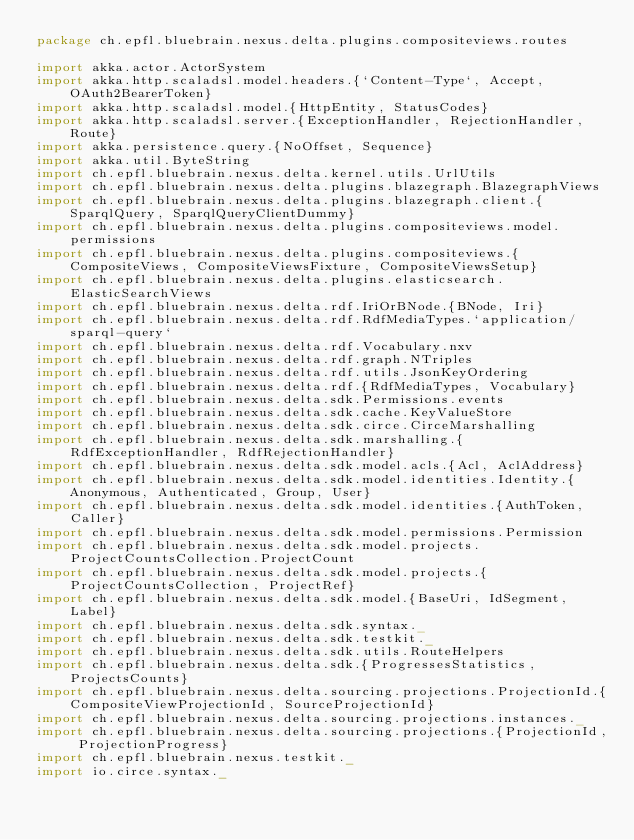<code> <loc_0><loc_0><loc_500><loc_500><_Scala_>package ch.epfl.bluebrain.nexus.delta.plugins.compositeviews.routes

import akka.actor.ActorSystem
import akka.http.scaladsl.model.headers.{`Content-Type`, Accept, OAuth2BearerToken}
import akka.http.scaladsl.model.{HttpEntity, StatusCodes}
import akka.http.scaladsl.server.{ExceptionHandler, RejectionHandler, Route}
import akka.persistence.query.{NoOffset, Sequence}
import akka.util.ByteString
import ch.epfl.bluebrain.nexus.delta.kernel.utils.UrlUtils
import ch.epfl.bluebrain.nexus.delta.plugins.blazegraph.BlazegraphViews
import ch.epfl.bluebrain.nexus.delta.plugins.blazegraph.client.{SparqlQuery, SparqlQueryClientDummy}
import ch.epfl.bluebrain.nexus.delta.plugins.compositeviews.model.permissions
import ch.epfl.bluebrain.nexus.delta.plugins.compositeviews.{CompositeViews, CompositeViewsFixture, CompositeViewsSetup}
import ch.epfl.bluebrain.nexus.delta.plugins.elasticsearch.ElasticSearchViews
import ch.epfl.bluebrain.nexus.delta.rdf.IriOrBNode.{BNode, Iri}
import ch.epfl.bluebrain.nexus.delta.rdf.RdfMediaTypes.`application/sparql-query`
import ch.epfl.bluebrain.nexus.delta.rdf.Vocabulary.nxv
import ch.epfl.bluebrain.nexus.delta.rdf.graph.NTriples
import ch.epfl.bluebrain.nexus.delta.rdf.utils.JsonKeyOrdering
import ch.epfl.bluebrain.nexus.delta.rdf.{RdfMediaTypes, Vocabulary}
import ch.epfl.bluebrain.nexus.delta.sdk.Permissions.events
import ch.epfl.bluebrain.nexus.delta.sdk.cache.KeyValueStore
import ch.epfl.bluebrain.nexus.delta.sdk.circe.CirceMarshalling
import ch.epfl.bluebrain.nexus.delta.sdk.marshalling.{RdfExceptionHandler, RdfRejectionHandler}
import ch.epfl.bluebrain.nexus.delta.sdk.model.acls.{Acl, AclAddress}
import ch.epfl.bluebrain.nexus.delta.sdk.model.identities.Identity.{Anonymous, Authenticated, Group, User}
import ch.epfl.bluebrain.nexus.delta.sdk.model.identities.{AuthToken, Caller}
import ch.epfl.bluebrain.nexus.delta.sdk.model.permissions.Permission
import ch.epfl.bluebrain.nexus.delta.sdk.model.projects.ProjectCountsCollection.ProjectCount
import ch.epfl.bluebrain.nexus.delta.sdk.model.projects.{ProjectCountsCollection, ProjectRef}
import ch.epfl.bluebrain.nexus.delta.sdk.model.{BaseUri, IdSegment, Label}
import ch.epfl.bluebrain.nexus.delta.sdk.syntax._
import ch.epfl.bluebrain.nexus.delta.sdk.testkit._
import ch.epfl.bluebrain.nexus.delta.sdk.utils.RouteHelpers
import ch.epfl.bluebrain.nexus.delta.sdk.{ProgressesStatistics, ProjectsCounts}
import ch.epfl.bluebrain.nexus.delta.sourcing.projections.ProjectionId.{CompositeViewProjectionId, SourceProjectionId}
import ch.epfl.bluebrain.nexus.delta.sourcing.projections.instances._
import ch.epfl.bluebrain.nexus.delta.sourcing.projections.{ProjectionId, ProjectionProgress}
import ch.epfl.bluebrain.nexus.testkit._
import io.circe.syntax._</code> 